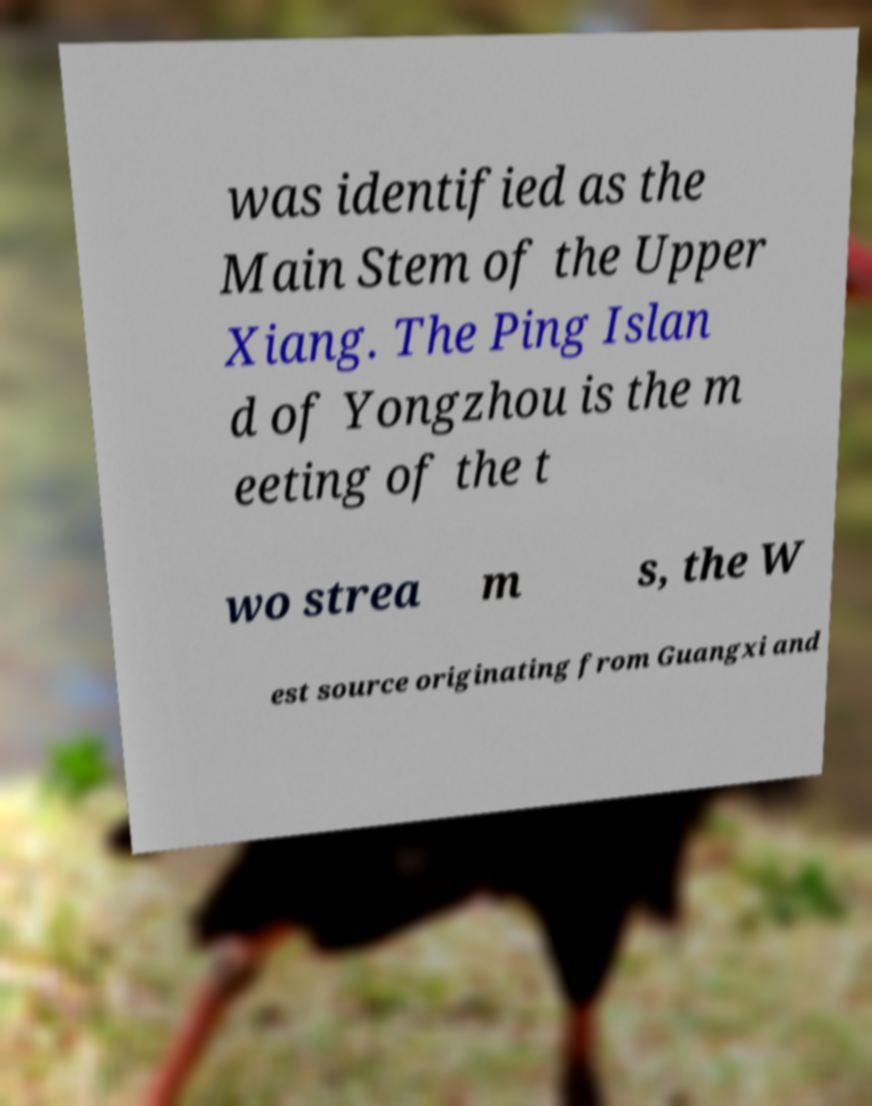There's text embedded in this image that I need extracted. Can you transcribe it verbatim? was identified as the Main Stem of the Upper Xiang. The Ping Islan d of Yongzhou is the m eeting of the t wo strea m s, the W est source originating from Guangxi and 